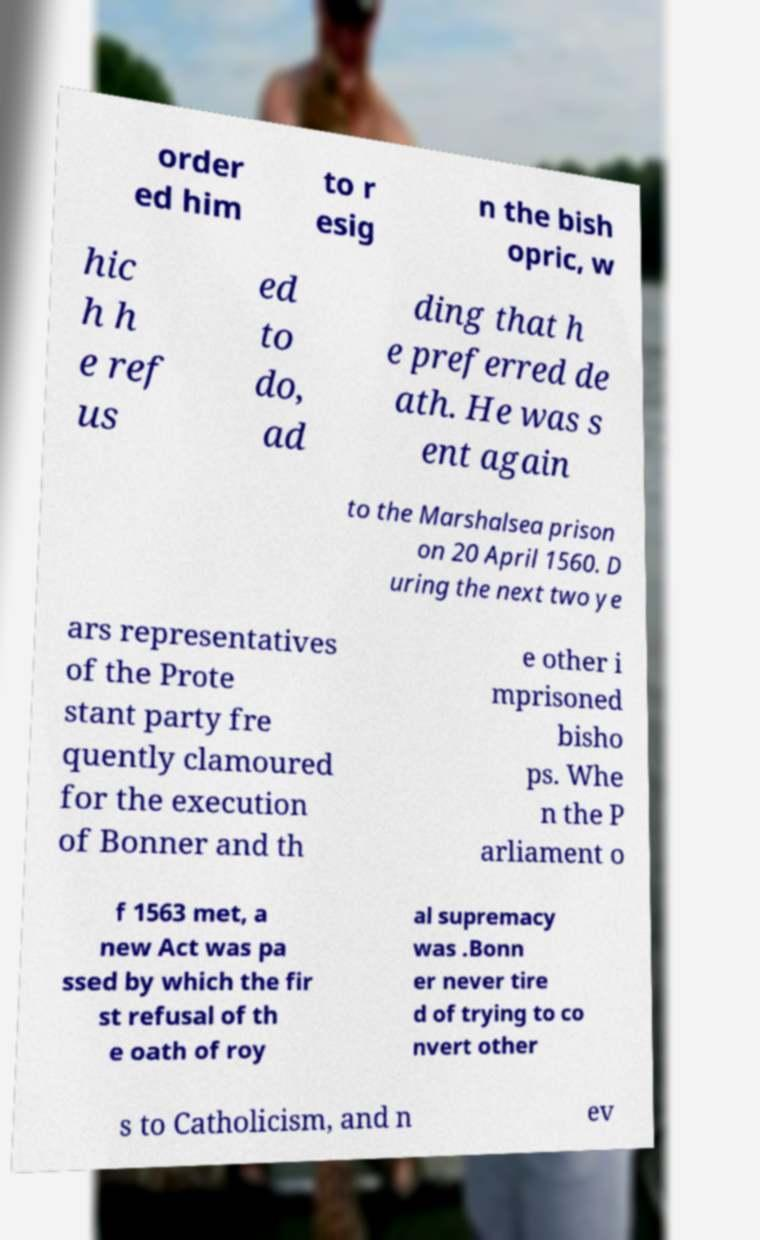Could you assist in decoding the text presented in this image and type it out clearly? order ed him to r esig n the bish opric, w hic h h e ref us ed to do, ad ding that h e preferred de ath. He was s ent again to the Marshalsea prison on 20 April 1560. D uring the next two ye ars representatives of the Prote stant party fre quently clamoured for the execution of Bonner and th e other i mprisoned bisho ps. Whe n the P arliament o f 1563 met, a new Act was pa ssed by which the fir st refusal of th e oath of roy al supremacy was .Bonn er never tire d of trying to co nvert other s to Catholicism, and n ev 